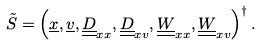<formula> <loc_0><loc_0><loc_500><loc_500>\tilde { S } = \left ( \underline { x } , \underline { v } , \underline { \underline { D } } _ { x x } , \underline { \underline { D } } _ { x v } , \underline { \underline { W } } _ { x x } , \underline { \underline { W } } _ { x v } \right ) ^ { \dagger } .</formula> 